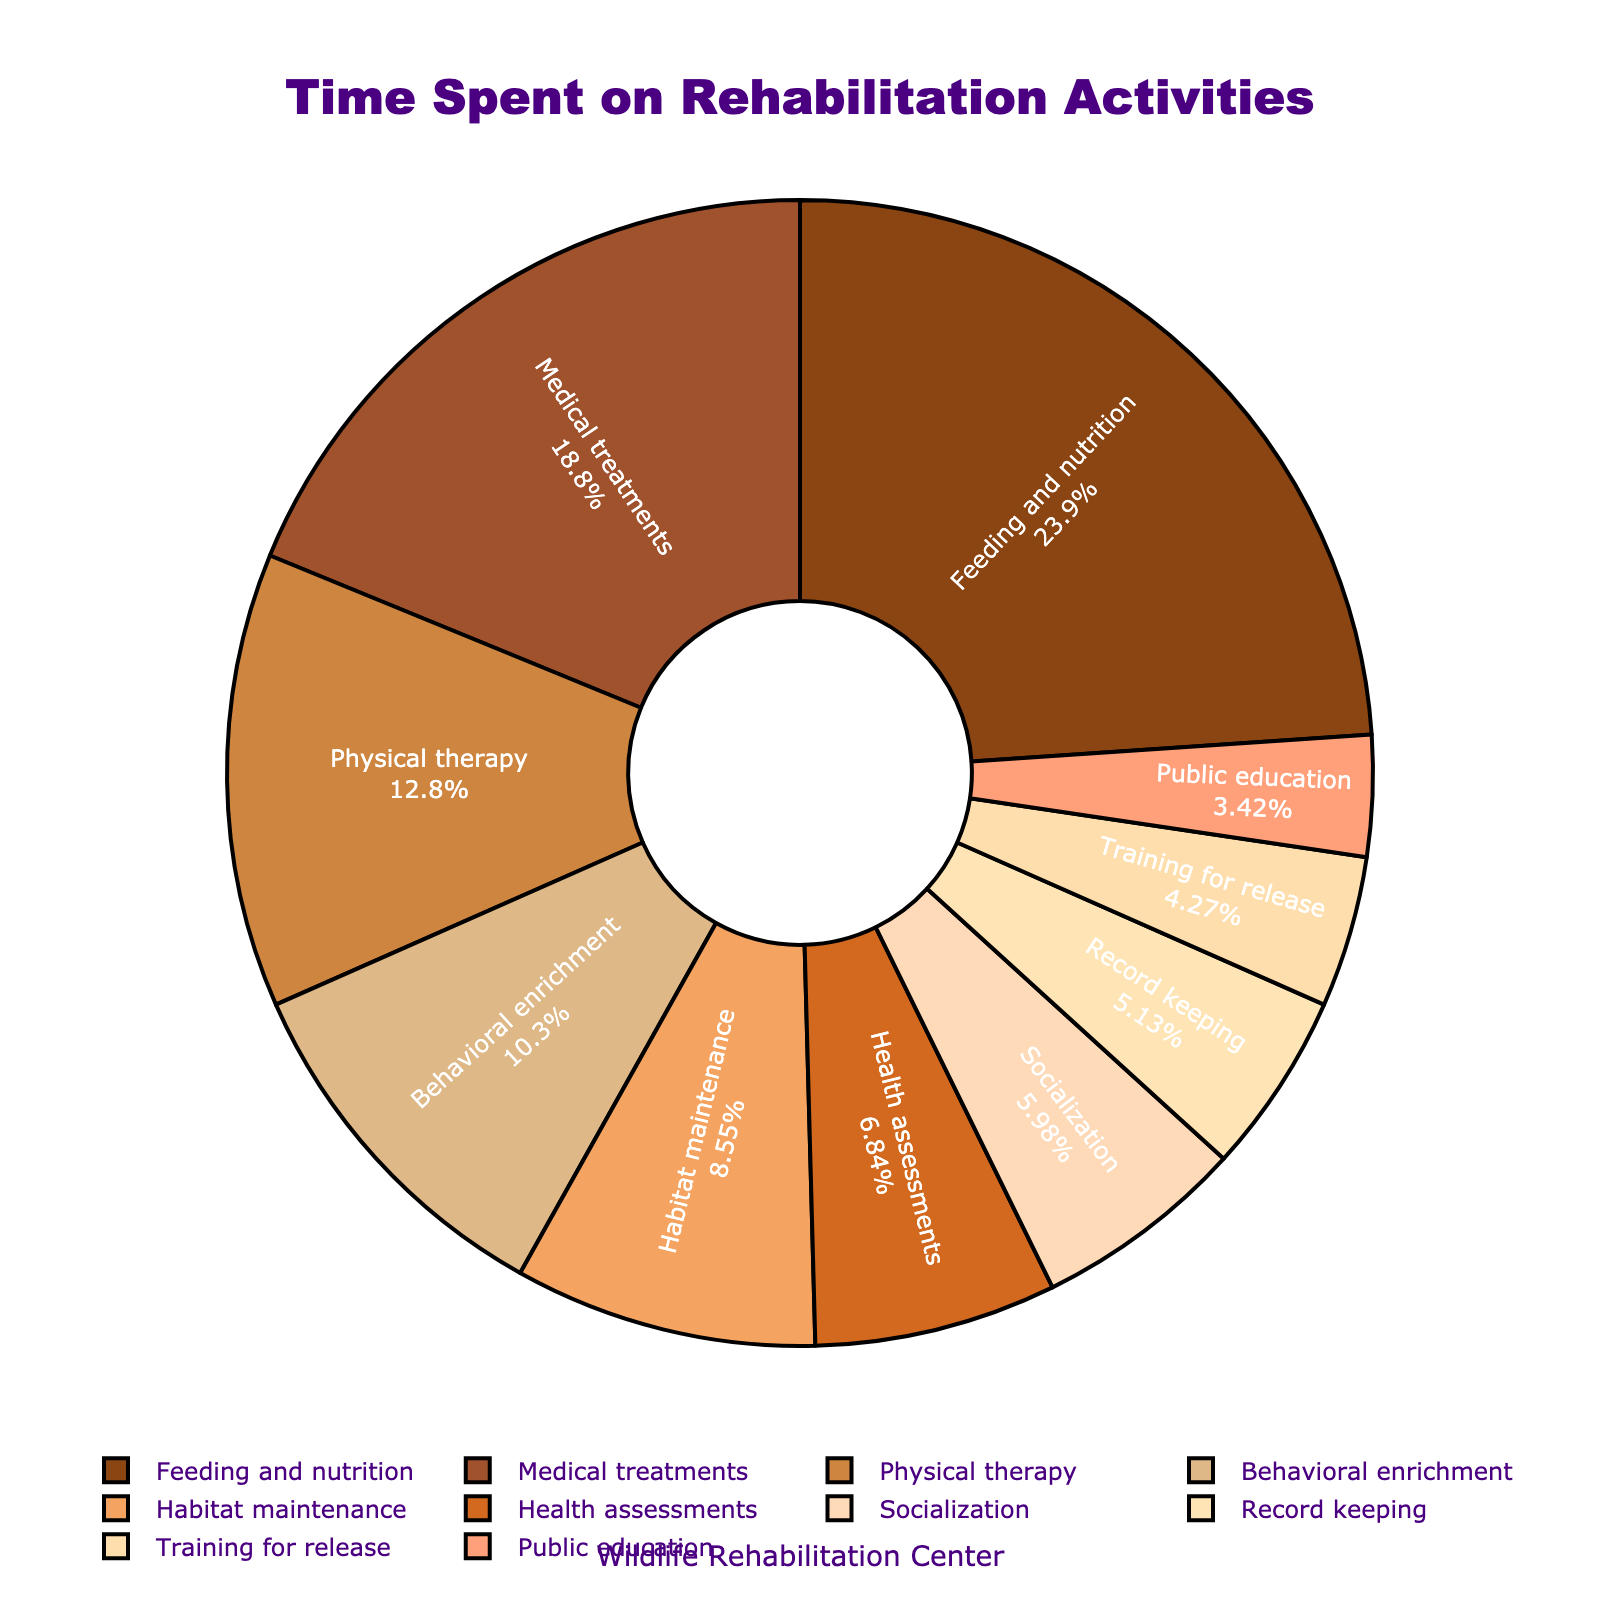How much time is spent on Medical Treatments compared to Physical Therapy? Medical treatments account for 22 hours, while Physical therapy has 15 hours. So, 22 - 15 = 7 hours more is spent on Medical Treatments compared to Physical Therapy.
Answer: 7 hours Which activity has the lowest time allocation? Public education has the lowest time allocation with 4 hours.
Answer: Public education How much time is spent on Feeding and Nutrition and Medical Treatments combined? Feeding and nutrition takes 28 hours, and Medical treatments take 22 hours. Combined, this is 28 + 22 = 50 hours.
Answer: 50 hours What is the percentage of time spent on Behavioral Enrichment? The total hours spent on all activities are 117. The percentage for Behavioral Enrichment is (12 / 117) * 100 ≈ 10.26%.
Answer: 10.26% Which activities take less time than Health Assessments? Socialization, Record keeping, Training for release, and Public education all take less time than Health assessments, which takes 8 hours.
Answer: Socialization, Record keeping, Training for release, Public education How much more time is spent on Feeding and Nutrition than on Training for Release? Feeding and Nutrition is allocated 28 hours, and Training for Release is given 5 hours. The difference is 28 - 5 = 23 hours.
Answer: 23 hours What activities are occupying more than 10% of the total time? Feeding and Nutrition is 28 hours (23.93%) and Medical treatments is 22 hours (18.80%). Both are over 10% of the total time.
Answer: Feeding and Nutrition, Medical treatments What is the combined percentage of time spent on Habitat Maintenance and Socialization? Habitat maintenance is 10 hours and socialization is 7 hours. Combined, they make 17 hours. The percentage is (17 / 117) * 100 ≈ 14.53%.
Answer: 14.53% Between Health Assessments and Record Keeping, which activity takes more time and by how much? Health Assessments take 8 hours, and Record keeping takes 6 hours. So, Health Assessments take 8 - 6 = 2 hours more.
Answer: Health Assessments by 2 hours If 10 more hours were allocated to Behavioral Enrichment, how much would its percentage of total time change? Current total is 117 hours; Behavioral Enrichment is 12 hours. Adding 10 more hours makes it 22 hours and a new total of 127 hours.
The new percentage is (22 / 127) * 100 ≈ 17.32%. Current is (12 / 117) * 100 ≈ 10.26%. The change is 17.32 - 10.26 ≈ 7.06%.
Answer: 7.06% 